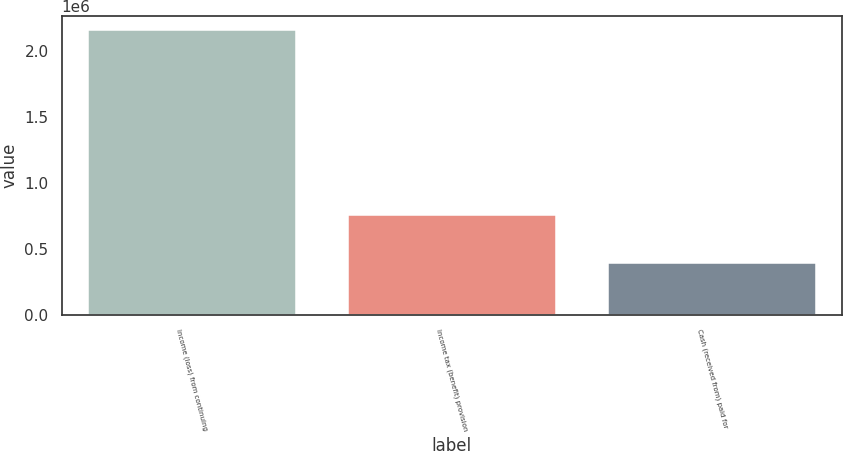Convert chart. <chart><loc_0><loc_0><loc_500><loc_500><bar_chart><fcel>Income (loss) from continuing<fcel>Income tax (benefit) provision<fcel>Cash (received from) paid for<nl><fcel>2.15843e+06<fcel>757883<fcel>391042<nl></chart> 